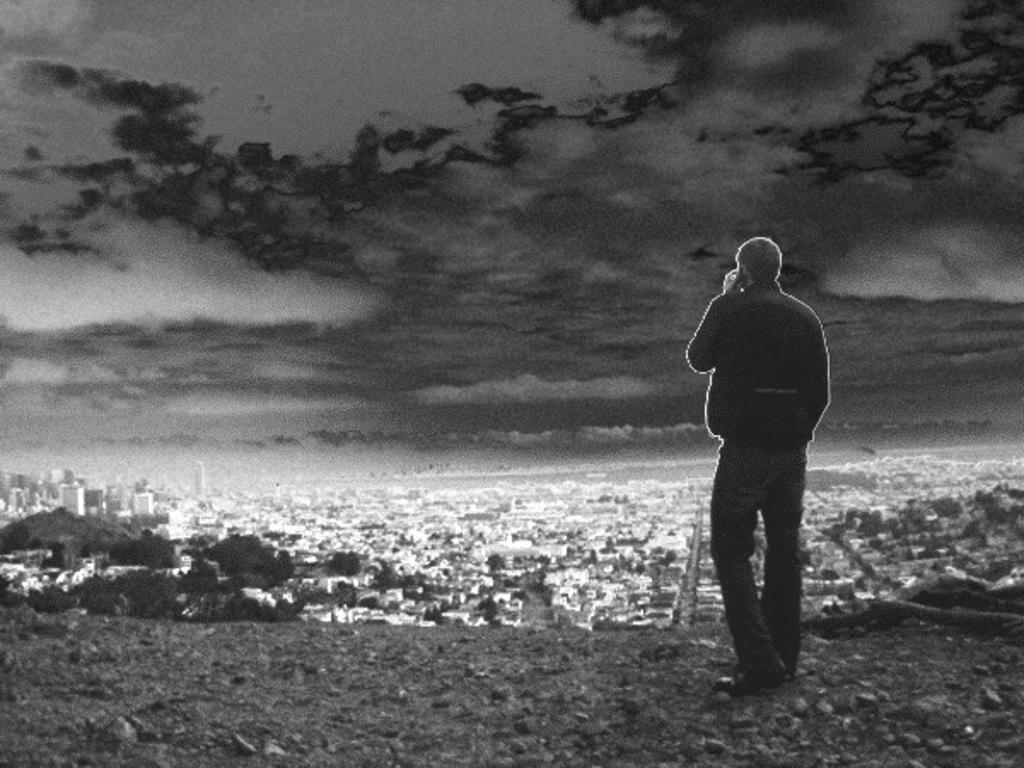Can you describe this image briefly? In the foreground of this black and white image, there is a man standing on the ground. In the background, we can see the city which includes, buildings, trees, skyscrapers, sky and the cloud. 